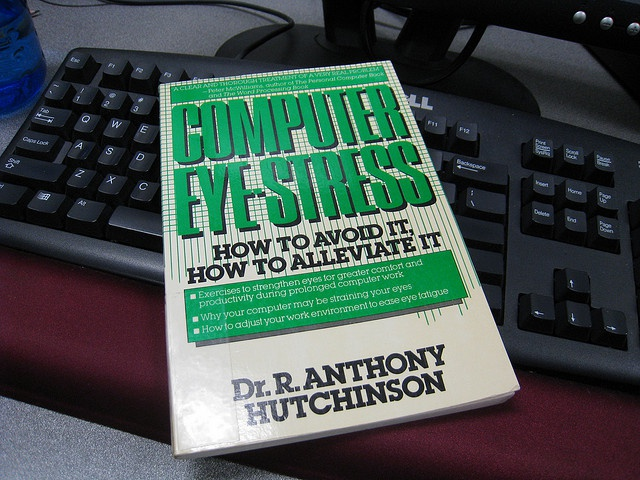Describe the objects in this image and their specific colors. I can see book in black, lightgray, and green tones and keyboard in black, gray, and darkblue tones in this image. 